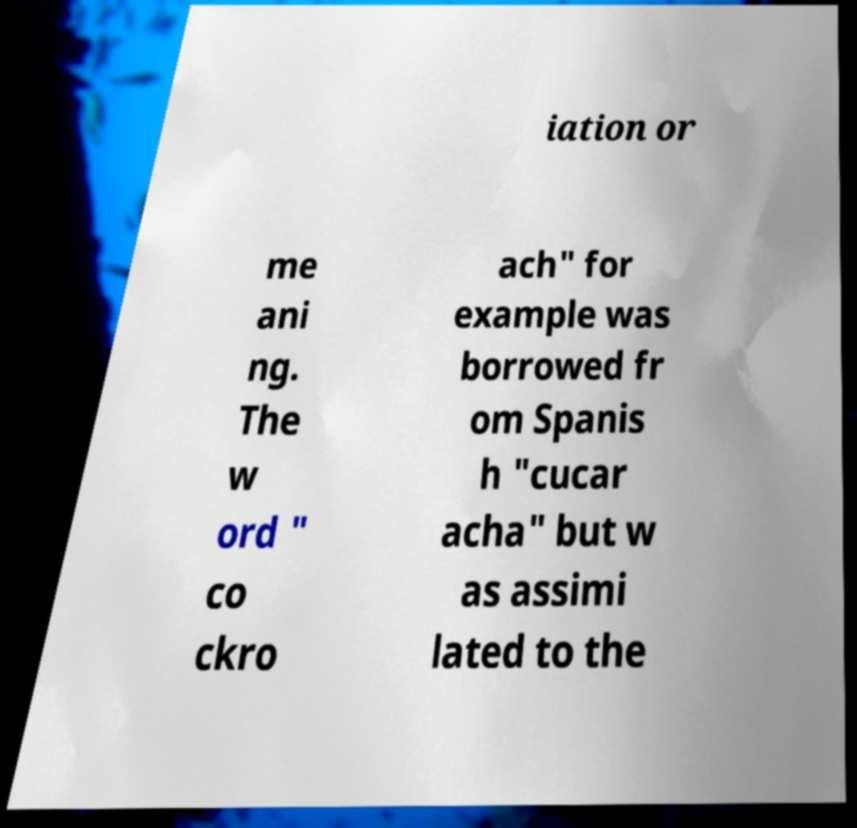For documentation purposes, I need the text within this image transcribed. Could you provide that? iation or me ani ng. The w ord " co ckro ach" for example was borrowed fr om Spanis h "cucar acha" but w as assimi lated to the 